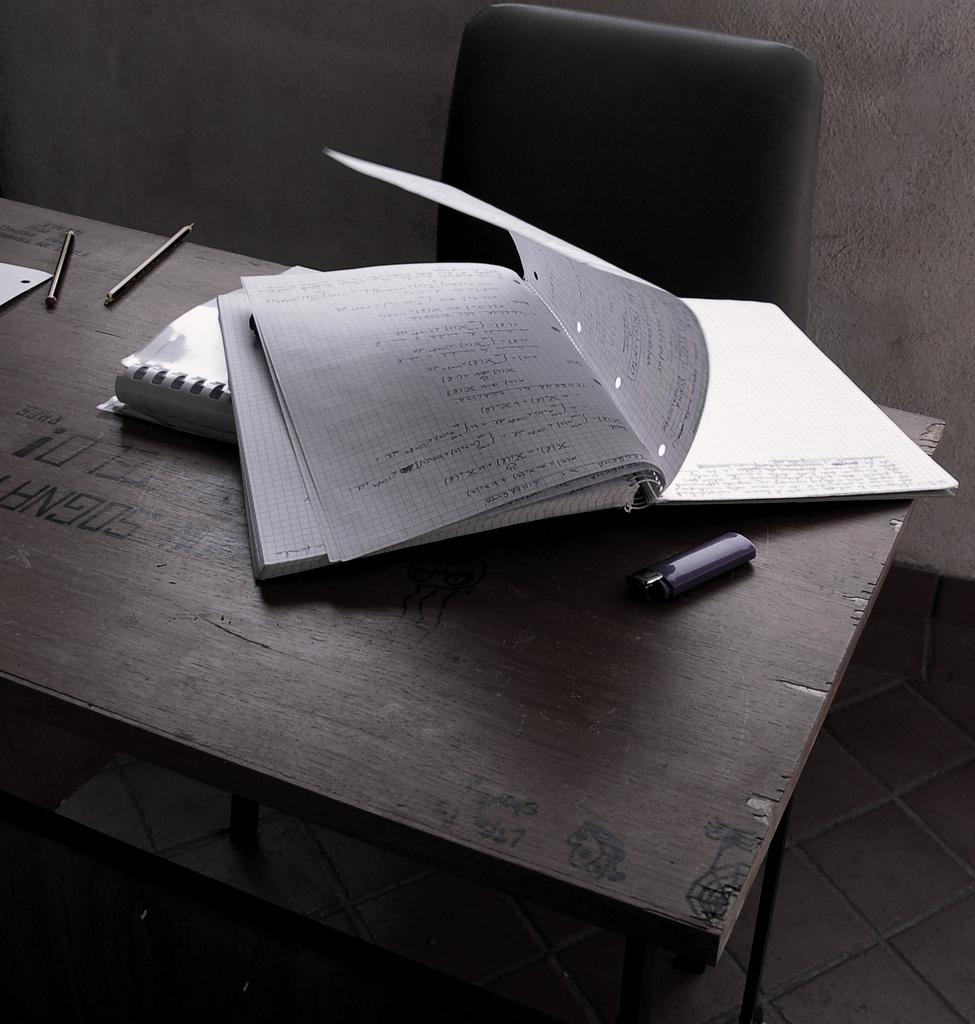Cannot read any of the text?
Provide a short and direct response. Not a question. 